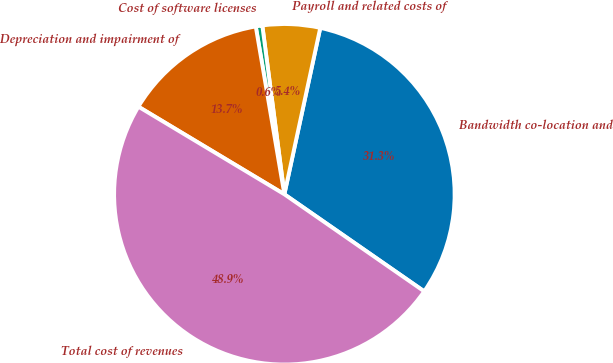Convert chart to OTSL. <chart><loc_0><loc_0><loc_500><loc_500><pie_chart><fcel>Bandwidth co-location and<fcel>Payroll and related costs of<fcel>Cost of software licenses<fcel>Depreciation and impairment of<fcel>Total cost of revenues<nl><fcel>31.28%<fcel>5.45%<fcel>0.62%<fcel>13.71%<fcel>48.95%<nl></chart> 